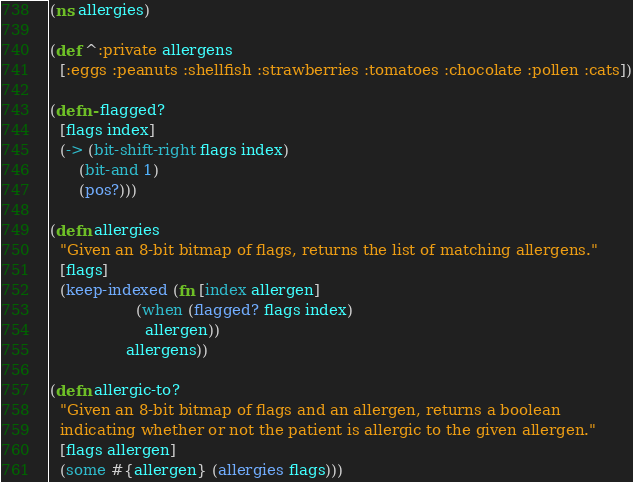<code> <loc_0><loc_0><loc_500><loc_500><_Clojure_>(ns allergies)

(def ^:private allergens
  [:eggs :peanuts :shellfish :strawberries :tomatoes :chocolate :pollen :cats])

(defn- flagged?
  [flags index]
  (-> (bit-shift-right flags index)
      (bit-and 1)
      (pos?)))

(defn allergies
  "Given an 8-bit bitmap of flags, returns the list of matching allergens."
  [flags]
  (keep-indexed (fn [index allergen]
                  (when (flagged? flags index)
                    allergen))
                allergens))

(defn allergic-to?
  "Given an 8-bit bitmap of flags and an allergen, returns a boolean
  indicating whether or not the patient is allergic to the given allergen."
  [flags allergen]
  (some #{allergen} (allergies flags)))
</code> 